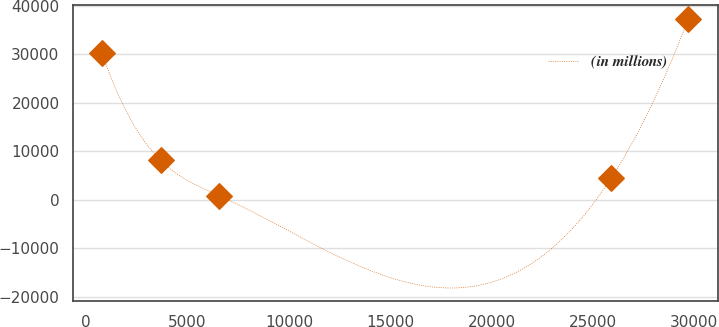<chart> <loc_0><loc_0><loc_500><loc_500><line_chart><ecel><fcel>(in millions)<nl><fcel>778.7<fcel>30213.6<nl><fcel>3670.18<fcel>8131.97<nl><fcel>6561.66<fcel>832.35<nl><fcel>25897.8<fcel>4482.16<nl><fcel>29693.5<fcel>37330.5<nl></chart> 